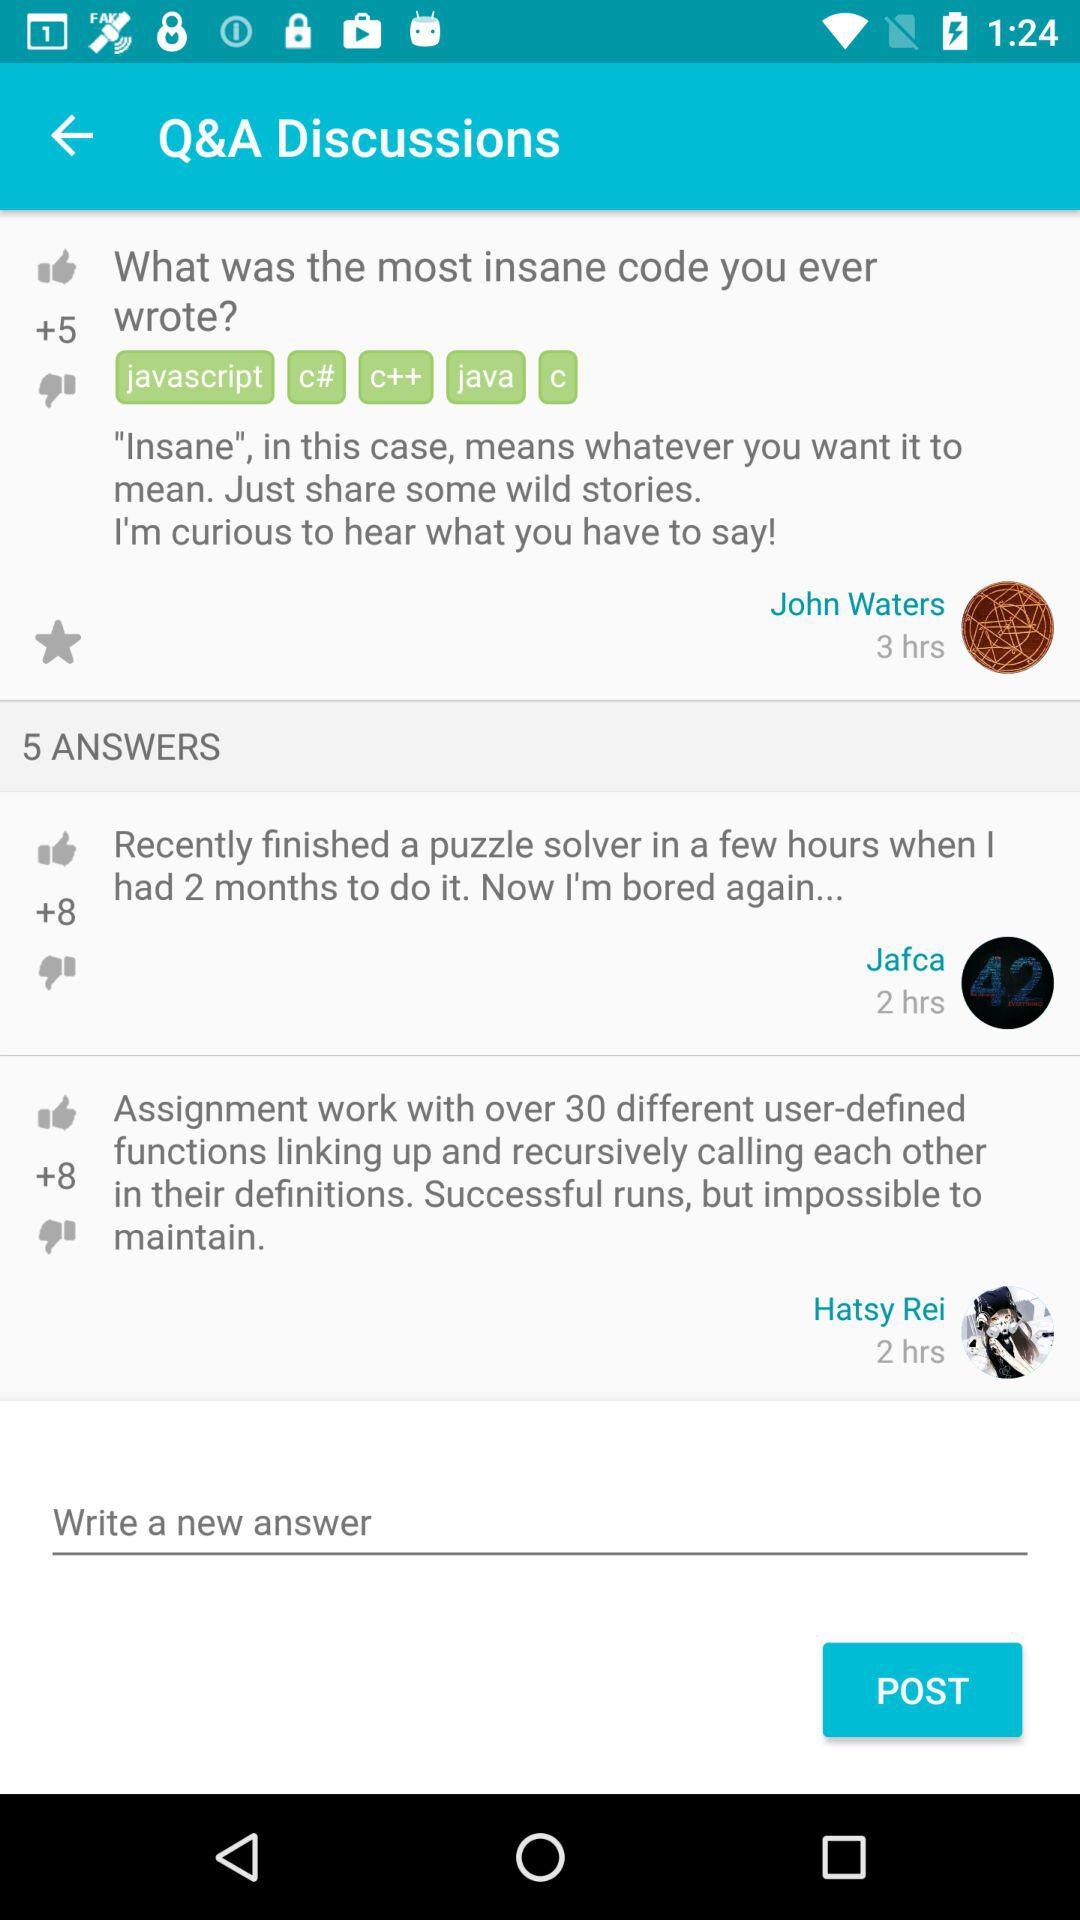How many thumbs up does the first answer have?
Answer the question using a single word or phrase. 5 